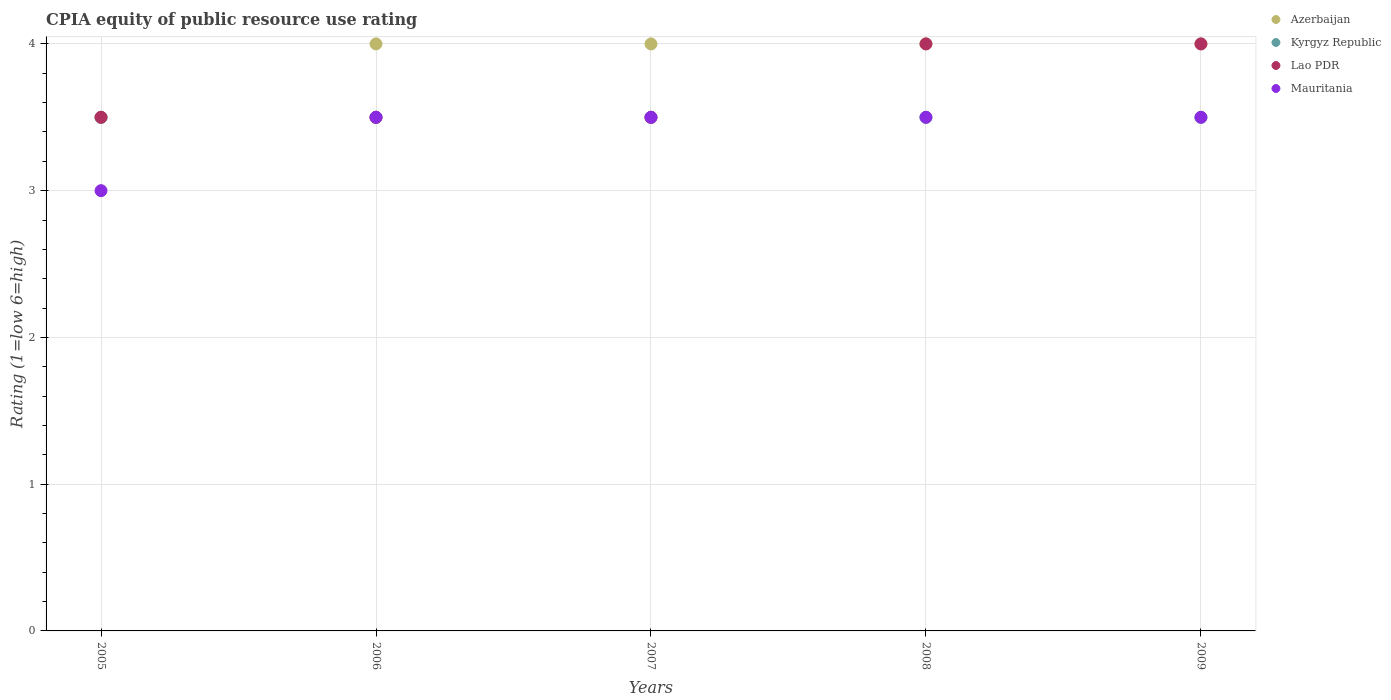What is the CPIA rating in Kyrgyz Republic in 2007?
Give a very brief answer. 3.5. Across all years, what is the minimum CPIA rating in Lao PDR?
Your response must be concise. 3.5. In which year was the CPIA rating in Lao PDR minimum?
Offer a very short reply. 2005. In the year 2008, what is the difference between the CPIA rating in Azerbaijan and CPIA rating in Mauritania?
Provide a short and direct response. 0.5. What is the ratio of the CPIA rating in Mauritania in 2006 to that in 2008?
Give a very brief answer. 1. Is the CPIA rating in Kyrgyz Republic in 2005 less than that in 2009?
Ensure brevity in your answer.  No. Is the difference between the CPIA rating in Azerbaijan in 2005 and 2008 greater than the difference between the CPIA rating in Mauritania in 2005 and 2008?
Your answer should be compact. No. What is the difference between the highest and the second highest CPIA rating in Kyrgyz Republic?
Offer a very short reply. 0. In how many years, is the CPIA rating in Lao PDR greater than the average CPIA rating in Lao PDR taken over all years?
Provide a short and direct response. 2. Is it the case that in every year, the sum of the CPIA rating in Mauritania and CPIA rating in Lao PDR  is greater than the sum of CPIA rating in Kyrgyz Republic and CPIA rating in Azerbaijan?
Your response must be concise. No. Does the CPIA rating in Mauritania monotonically increase over the years?
Offer a very short reply. No. Is the CPIA rating in Azerbaijan strictly greater than the CPIA rating in Kyrgyz Republic over the years?
Provide a succinct answer. No. How many years are there in the graph?
Make the answer very short. 5. What is the difference between two consecutive major ticks on the Y-axis?
Your answer should be compact. 1. Are the values on the major ticks of Y-axis written in scientific E-notation?
Keep it short and to the point. No. Does the graph contain grids?
Provide a succinct answer. Yes. Where does the legend appear in the graph?
Ensure brevity in your answer.  Top right. How many legend labels are there?
Make the answer very short. 4. What is the title of the graph?
Your answer should be very brief. CPIA equity of public resource use rating. What is the Rating (1=low 6=high) in Azerbaijan in 2005?
Offer a terse response. 3.5. What is the Rating (1=low 6=high) of Kyrgyz Republic in 2005?
Ensure brevity in your answer.  3.5. What is the Rating (1=low 6=high) of Azerbaijan in 2006?
Your answer should be very brief. 4. What is the Rating (1=low 6=high) in Kyrgyz Republic in 2006?
Your answer should be compact. 3.5. What is the Rating (1=low 6=high) of Lao PDR in 2006?
Offer a very short reply. 3.5. What is the Rating (1=low 6=high) of Azerbaijan in 2007?
Offer a terse response. 4. What is the Rating (1=low 6=high) in Lao PDR in 2007?
Offer a very short reply. 3.5. What is the Rating (1=low 6=high) of Mauritania in 2007?
Your response must be concise. 3.5. What is the Rating (1=low 6=high) of Azerbaijan in 2008?
Your answer should be compact. 4. What is the Rating (1=low 6=high) of Azerbaijan in 2009?
Your answer should be very brief. 4. What is the Rating (1=low 6=high) of Lao PDR in 2009?
Offer a very short reply. 4. Across all years, what is the maximum Rating (1=low 6=high) in Azerbaijan?
Give a very brief answer. 4. Across all years, what is the maximum Rating (1=low 6=high) of Lao PDR?
Your answer should be compact. 4. Across all years, what is the minimum Rating (1=low 6=high) of Kyrgyz Republic?
Your response must be concise. 3.5. Across all years, what is the minimum Rating (1=low 6=high) in Lao PDR?
Offer a very short reply. 3.5. Across all years, what is the minimum Rating (1=low 6=high) in Mauritania?
Your response must be concise. 3. What is the total Rating (1=low 6=high) in Azerbaijan in the graph?
Your answer should be compact. 19.5. What is the total Rating (1=low 6=high) of Kyrgyz Republic in the graph?
Provide a succinct answer. 17.5. What is the total Rating (1=low 6=high) of Mauritania in the graph?
Offer a terse response. 17. What is the difference between the Rating (1=low 6=high) of Lao PDR in 2005 and that in 2006?
Ensure brevity in your answer.  0. What is the difference between the Rating (1=low 6=high) in Mauritania in 2005 and that in 2006?
Ensure brevity in your answer.  -0.5. What is the difference between the Rating (1=low 6=high) of Azerbaijan in 2005 and that in 2007?
Provide a succinct answer. -0.5. What is the difference between the Rating (1=low 6=high) in Mauritania in 2005 and that in 2007?
Make the answer very short. -0.5. What is the difference between the Rating (1=low 6=high) in Azerbaijan in 2005 and that in 2009?
Your answer should be very brief. -0.5. What is the difference between the Rating (1=low 6=high) in Kyrgyz Republic in 2005 and that in 2009?
Your answer should be compact. 0. What is the difference between the Rating (1=low 6=high) of Mauritania in 2005 and that in 2009?
Give a very brief answer. -0.5. What is the difference between the Rating (1=low 6=high) in Kyrgyz Republic in 2006 and that in 2007?
Give a very brief answer. 0. What is the difference between the Rating (1=low 6=high) of Lao PDR in 2006 and that in 2007?
Ensure brevity in your answer.  0. What is the difference between the Rating (1=low 6=high) of Azerbaijan in 2006 and that in 2008?
Offer a very short reply. 0. What is the difference between the Rating (1=low 6=high) in Kyrgyz Republic in 2006 and that in 2008?
Make the answer very short. 0. What is the difference between the Rating (1=low 6=high) of Lao PDR in 2006 and that in 2008?
Ensure brevity in your answer.  -0.5. What is the difference between the Rating (1=low 6=high) in Mauritania in 2006 and that in 2008?
Make the answer very short. 0. What is the difference between the Rating (1=low 6=high) in Lao PDR in 2007 and that in 2008?
Your answer should be compact. -0.5. What is the difference between the Rating (1=low 6=high) of Mauritania in 2007 and that in 2008?
Your answer should be very brief. 0. What is the difference between the Rating (1=low 6=high) in Azerbaijan in 2007 and that in 2009?
Make the answer very short. 0. What is the difference between the Rating (1=low 6=high) in Kyrgyz Republic in 2007 and that in 2009?
Keep it short and to the point. 0. What is the difference between the Rating (1=low 6=high) in Lao PDR in 2007 and that in 2009?
Keep it short and to the point. -0.5. What is the difference between the Rating (1=low 6=high) in Mauritania in 2007 and that in 2009?
Your response must be concise. 0. What is the difference between the Rating (1=low 6=high) of Lao PDR in 2008 and that in 2009?
Offer a terse response. 0. What is the difference between the Rating (1=low 6=high) in Azerbaijan in 2005 and the Rating (1=low 6=high) in Kyrgyz Republic in 2006?
Your response must be concise. 0. What is the difference between the Rating (1=low 6=high) in Kyrgyz Republic in 2005 and the Rating (1=low 6=high) in Lao PDR in 2006?
Offer a very short reply. 0. What is the difference between the Rating (1=low 6=high) of Kyrgyz Republic in 2005 and the Rating (1=low 6=high) of Mauritania in 2006?
Make the answer very short. 0. What is the difference between the Rating (1=low 6=high) in Lao PDR in 2005 and the Rating (1=low 6=high) in Mauritania in 2006?
Ensure brevity in your answer.  0. What is the difference between the Rating (1=low 6=high) in Azerbaijan in 2005 and the Rating (1=low 6=high) in Kyrgyz Republic in 2007?
Your answer should be very brief. 0. What is the difference between the Rating (1=low 6=high) of Azerbaijan in 2005 and the Rating (1=low 6=high) of Mauritania in 2007?
Provide a succinct answer. 0. What is the difference between the Rating (1=low 6=high) in Kyrgyz Republic in 2005 and the Rating (1=low 6=high) in Lao PDR in 2007?
Ensure brevity in your answer.  0. What is the difference between the Rating (1=low 6=high) of Azerbaijan in 2005 and the Rating (1=low 6=high) of Mauritania in 2008?
Keep it short and to the point. 0. What is the difference between the Rating (1=low 6=high) in Kyrgyz Republic in 2005 and the Rating (1=low 6=high) in Mauritania in 2008?
Offer a terse response. 0. What is the difference between the Rating (1=low 6=high) of Lao PDR in 2005 and the Rating (1=low 6=high) of Mauritania in 2008?
Offer a terse response. 0. What is the difference between the Rating (1=low 6=high) in Azerbaijan in 2005 and the Rating (1=low 6=high) in Kyrgyz Republic in 2009?
Give a very brief answer. 0. What is the difference between the Rating (1=low 6=high) in Azerbaijan in 2005 and the Rating (1=low 6=high) in Lao PDR in 2009?
Keep it short and to the point. -0.5. What is the difference between the Rating (1=low 6=high) in Kyrgyz Republic in 2005 and the Rating (1=low 6=high) in Lao PDR in 2009?
Offer a very short reply. -0.5. What is the difference between the Rating (1=low 6=high) of Kyrgyz Republic in 2005 and the Rating (1=low 6=high) of Mauritania in 2009?
Keep it short and to the point. 0. What is the difference between the Rating (1=low 6=high) of Azerbaijan in 2006 and the Rating (1=low 6=high) of Kyrgyz Republic in 2007?
Give a very brief answer. 0.5. What is the difference between the Rating (1=low 6=high) in Azerbaijan in 2006 and the Rating (1=low 6=high) in Lao PDR in 2007?
Your answer should be compact. 0.5. What is the difference between the Rating (1=low 6=high) of Azerbaijan in 2006 and the Rating (1=low 6=high) of Mauritania in 2007?
Your answer should be compact. 0.5. What is the difference between the Rating (1=low 6=high) in Kyrgyz Republic in 2006 and the Rating (1=low 6=high) in Lao PDR in 2007?
Offer a terse response. 0. What is the difference between the Rating (1=low 6=high) in Azerbaijan in 2006 and the Rating (1=low 6=high) in Mauritania in 2008?
Make the answer very short. 0.5. What is the difference between the Rating (1=low 6=high) in Kyrgyz Republic in 2006 and the Rating (1=low 6=high) in Lao PDR in 2008?
Your response must be concise. -0.5. What is the difference between the Rating (1=low 6=high) of Azerbaijan in 2006 and the Rating (1=low 6=high) of Kyrgyz Republic in 2009?
Your answer should be very brief. 0.5. What is the difference between the Rating (1=low 6=high) in Azerbaijan in 2006 and the Rating (1=low 6=high) in Mauritania in 2009?
Your answer should be very brief. 0.5. What is the difference between the Rating (1=low 6=high) of Kyrgyz Republic in 2006 and the Rating (1=low 6=high) of Lao PDR in 2009?
Your answer should be very brief. -0.5. What is the difference between the Rating (1=low 6=high) in Kyrgyz Republic in 2006 and the Rating (1=low 6=high) in Mauritania in 2009?
Ensure brevity in your answer.  0. What is the difference between the Rating (1=low 6=high) in Lao PDR in 2006 and the Rating (1=low 6=high) in Mauritania in 2009?
Offer a terse response. 0. What is the difference between the Rating (1=low 6=high) in Kyrgyz Republic in 2007 and the Rating (1=low 6=high) in Lao PDR in 2008?
Provide a short and direct response. -0.5. What is the difference between the Rating (1=low 6=high) of Kyrgyz Republic in 2007 and the Rating (1=low 6=high) of Mauritania in 2008?
Your answer should be very brief. 0. What is the difference between the Rating (1=low 6=high) of Lao PDR in 2007 and the Rating (1=low 6=high) of Mauritania in 2008?
Make the answer very short. 0. What is the difference between the Rating (1=low 6=high) of Azerbaijan in 2007 and the Rating (1=low 6=high) of Lao PDR in 2009?
Your answer should be compact. 0. What is the difference between the Rating (1=low 6=high) in Kyrgyz Republic in 2007 and the Rating (1=low 6=high) in Lao PDR in 2009?
Your answer should be compact. -0.5. What is the difference between the Rating (1=low 6=high) in Azerbaijan in 2008 and the Rating (1=low 6=high) in Lao PDR in 2009?
Ensure brevity in your answer.  0. What is the difference between the Rating (1=low 6=high) of Azerbaijan in 2008 and the Rating (1=low 6=high) of Mauritania in 2009?
Your answer should be very brief. 0.5. What is the difference between the Rating (1=low 6=high) in Kyrgyz Republic in 2008 and the Rating (1=low 6=high) in Lao PDR in 2009?
Make the answer very short. -0.5. In the year 2005, what is the difference between the Rating (1=low 6=high) of Azerbaijan and Rating (1=low 6=high) of Mauritania?
Provide a short and direct response. 0.5. In the year 2005, what is the difference between the Rating (1=low 6=high) of Kyrgyz Republic and Rating (1=low 6=high) of Lao PDR?
Your answer should be compact. 0. In the year 2005, what is the difference between the Rating (1=low 6=high) of Kyrgyz Republic and Rating (1=low 6=high) of Mauritania?
Your response must be concise. 0.5. In the year 2005, what is the difference between the Rating (1=low 6=high) in Lao PDR and Rating (1=low 6=high) in Mauritania?
Offer a terse response. 0.5. In the year 2007, what is the difference between the Rating (1=low 6=high) in Azerbaijan and Rating (1=low 6=high) in Kyrgyz Republic?
Your answer should be very brief. 0.5. In the year 2007, what is the difference between the Rating (1=low 6=high) of Azerbaijan and Rating (1=low 6=high) of Lao PDR?
Ensure brevity in your answer.  0.5. In the year 2007, what is the difference between the Rating (1=low 6=high) in Lao PDR and Rating (1=low 6=high) in Mauritania?
Your answer should be compact. 0. In the year 2008, what is the difference between the Rating (1=low 6=high) in Kyrgyz Republic and Rating (1=low 6=high) in Lao PDR?
Ensure brevity in your answer.  -0.5. In the year 2008, what is the difference between the Rating (1=low 6=high) in Lao PDR and Rating (1=low 6=high) in Mauritania?
Provide a succinct answer. 0.5. In the year 2009, what is the difference between the Rating (1=low 6=high) in Azerbaijan and Rating (1=low 6=high) in Kyrgyz Republic?
Provide a succinct answer. 0.5. In the year 2009, what is the difference between the Rating (1=low 6=high) of Kyrgyz Republic and Rating (1=low 6=high) of Mauritania?
Provide a short and direct response. 0. What is the ratio of the Rating (1=low 6=high) of Kyrgyz Republic in 2005 to that in 2006?
Offer a terse response. 1. What is the ratio of the Rating (1=low 6=high) in Azerbaijan in 2005 to that in 2007?
Your response must be concise. 0.88. What is the ratio of the Rating (1=low 6=high) in Azerbaijan in 2005 to that in 2008?
Your response must be concise. 0.88. What is the ratio of the Rating (1=low 6=high) in Mauritania in 2005 to that in 2008?
Ensure brevity in your answer.  0.86. What is the ratio of the Rating (1=low 6=high) of Kyrgyz Republic in 2005 to that in 2009?
Your response must be concise. 1. What is the ratio of the Rating (1=low 6=high) of Kyrgyz Republic in 2006 to that in 2007?
Make the answer very short. 1. What is the ratio of the Rating (1=low 6=high) of Mauritania in 2006 to that in 2007?
Offer a terse response. 1. What is the ratio of the Rating (1=low 6=high) in Mauritania in 2006 to that in 2008?
Provide a succinct answer. 1. What is the ratio of the Rating (1=low 6=high) in Azerbaijan in 2006 to that in 2009?
Give a very brief answer. 1. What is the ratio of the Rating (1=low 6=high) of Kyrgyz Republic in 2006 to that in 2009?
Give a very brief answer. 1. What is the ratio of the Rating (1=low 6=high) of Mauritania in 2006 to that in 2009?
Your answer should be compact. 1. What is the ratio of the Rating (1=low 6=high) of Azerbaijan in 2007 to that in 2008?
Give a very brief answer. 1. What is the ratio of the Rating (1=low 6=high) of Lao PDR in 2007 to that in 2008?
Keep it short and to the point. 0.88. What is the ratio of the Rating (1=low 6=high) in Kyrgyz Republic in 2007 to that in 2009?
Make the answer very short. 1. What is the ratio of the Rating (1=low 6=high) in Lao PDR in 2007 to that in 2009?
Give a very brief answer. 0.88. What is the ratio of the Rating (1=low 6=high) of Mauritania in 2007 to that in 2009?
Your answer should be very brief. 1. What is the ratio of the Rating (1=low 6=high) in Azerbaijan in 2008 to that in 2009?
Provide a succinct answer. 1. What is the ratio of the Rating (1=low 6=high) in Kyrgyz Republic in 2008 to that in 2009?
Provide a succinct answer. 1. What is the ratio of the Rating (1=low 6=high) in Lao PDR in 2008 to that in 2009?
Provide a succinct answer. 1. What is the ratio of the Rating (1=low 6=high) in Mauritania in 2008 to that in 2009?
Ensure brevity in your answer.  1. What is the difference between the highest and the second highest Rating (1=low 6=high) in Azerbaijan?
Offer a terse response. 0. What is the difference between the highest and the second highest Rating (1=low 6=high) in Lao PDR?
Your response must be concise. 0. What is the difference between the highest and the second highest Rating (1=low 6=high) of Mauritania?
Your answer should be very brief. 0. What is the difference between the highest and the lowest Rating (1=low 6=high) of Azerbaijan?
Your answer should be compact. 0.5. What is the difference between the highest and the lowest Rating (1=low 6=high) in Kyrgyz Republic?
Offer a terse response. 0. What is the difference between the highest and the lowest Rating (1=low 6=high) in Lao PDR?
Your answer should be compact. 0.5. What is the difference between the highest and the lowest Rating (1=low 6=high) in Mauritania?
Give a very brief answer. 0.5. 